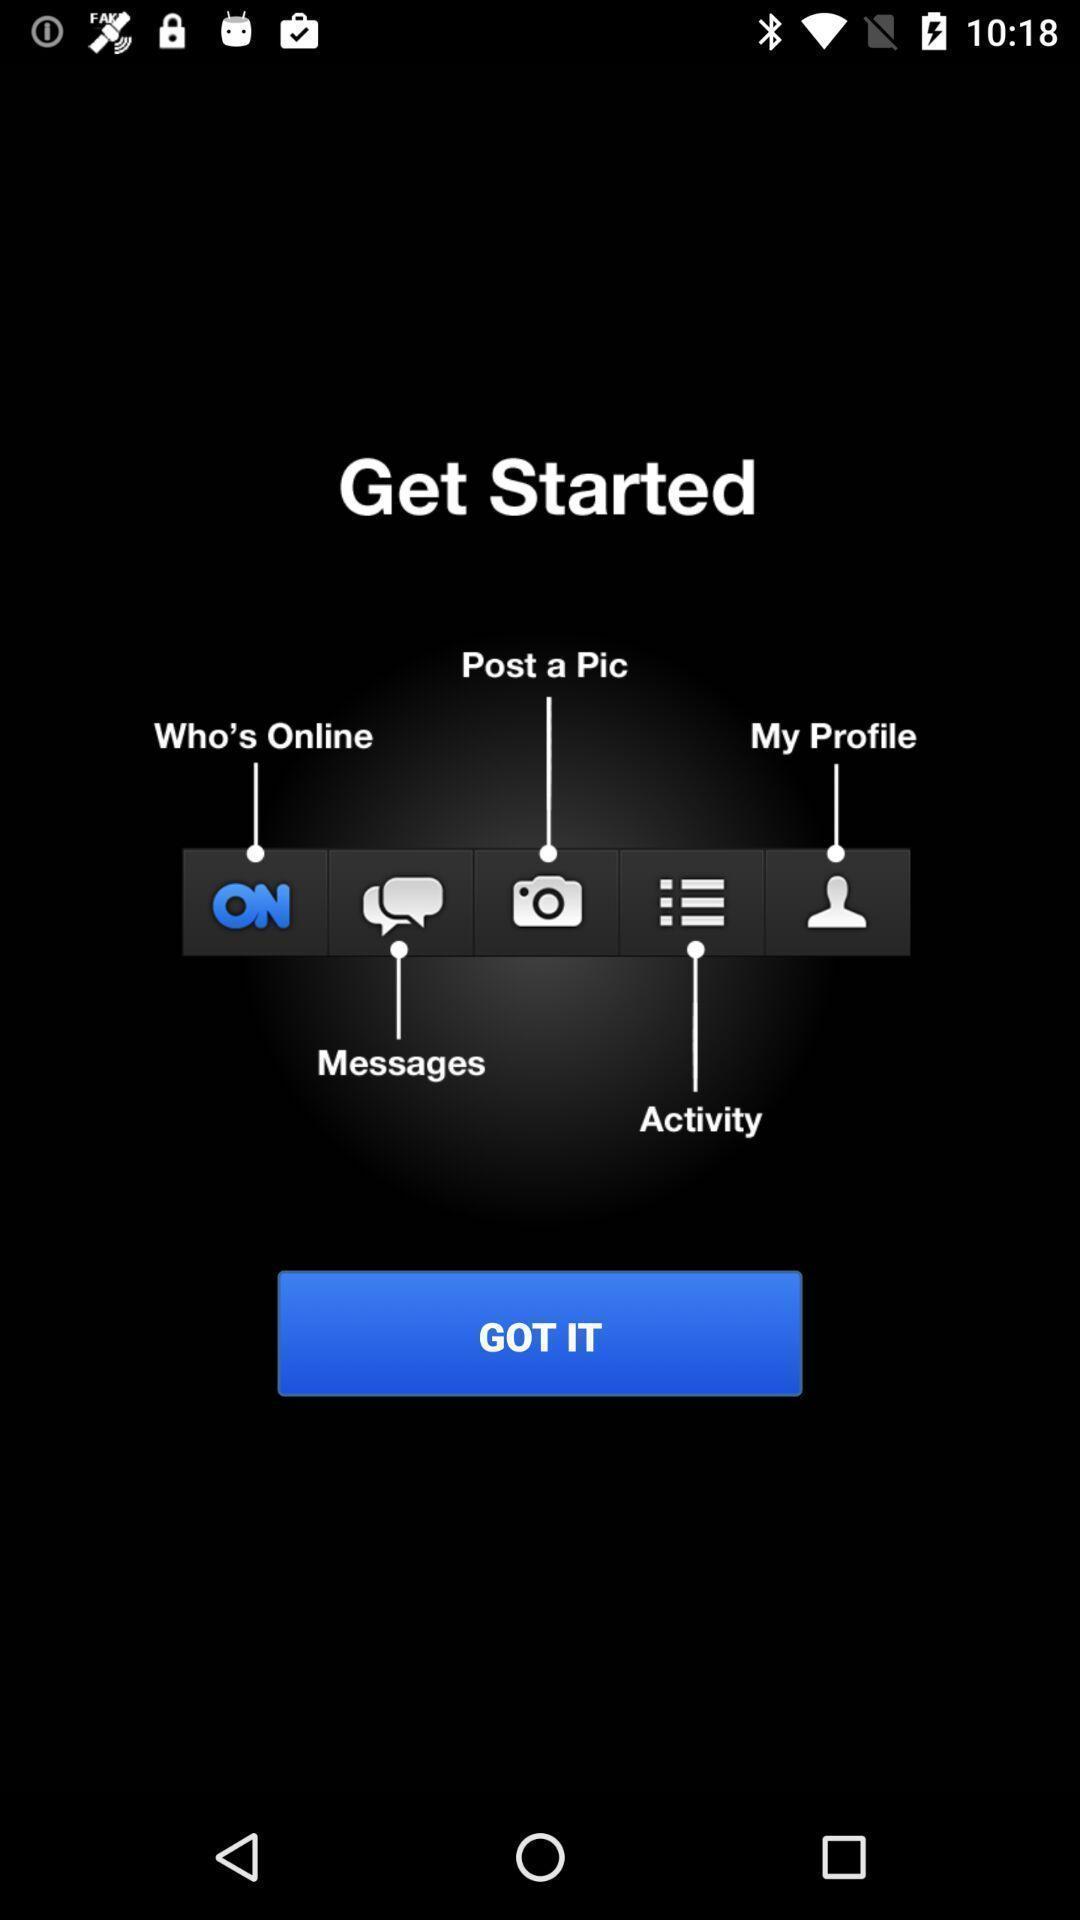Provide a textual representation of this image. Screen shows icons information in the social application. 